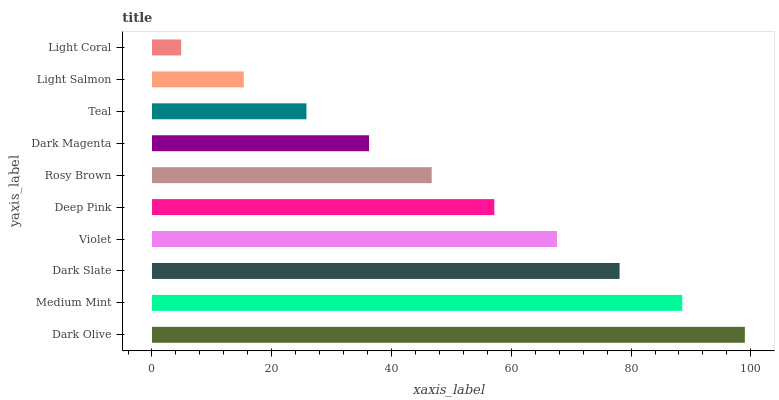Is Light Coral the minimum?
Answer yes or no. Yes. Is Dark Olive the maximum?
Answer yes or no. Yes. Is Medium Mint the minimum?
Answer yes or no. No. Is Medium Mint the maximum?
Answer yes or no. No. Is Dark Olive greater than Medium Mint?
Answer yes or no. Yes. Is Medium Mint less than Dark Olive?
Answer yes or no. Yes. Is Medium Mint greater than Dark Olive?
Answer yes or no. No. Is Dark Olive less than Medium Mint?
Answer yes or no. No. Is Deep Pink the high median?
Answer yes or no. Yes. Is Rosy Brown the low median?
Answer yes or no. Yes. Is Teal the high median?
Answer yes or no. No. Is Violet the low median?
Answer yes or no. No. 